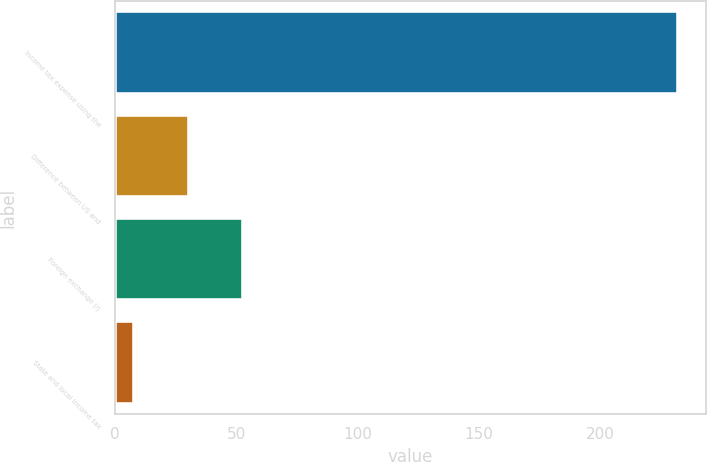Convert chart. <chart><loc_0><loc_0><loc_500><loc_500><bar_chart><fcel>Income tax expense using the<fcel>Difference between US and<fcel>Foreign exchange (i)<fcel>State and local income tax<nl><fcel>231.9<fcel>30.48<fcel>52.86<fcel>8.1<nl></chart> 